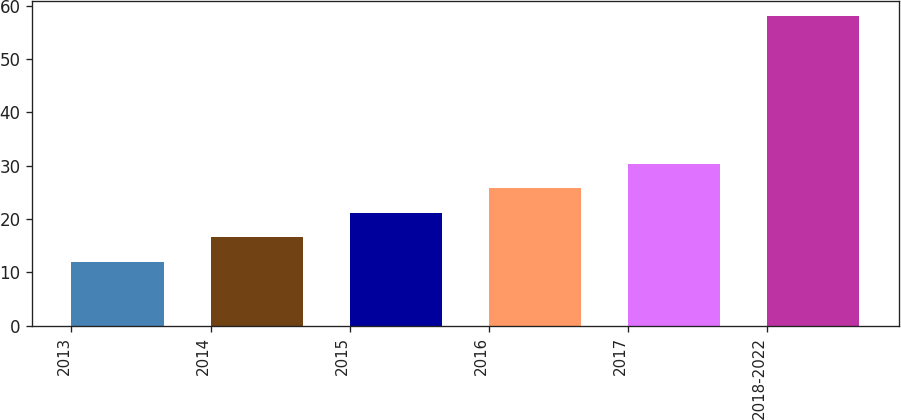Convert chart to OTSL. <chart><loc_0><loc_0><loc_500><loc_500><bar_chart><fcel>2013<fcel>2014<fcel>2015<fcel>2016<fcel>2017<fcel>2018-2022<nl><fcel>12<fcel>16.6<fcel>21.2<fcel>25.8<fcel>30.4<fcel>58<nl></chart> 